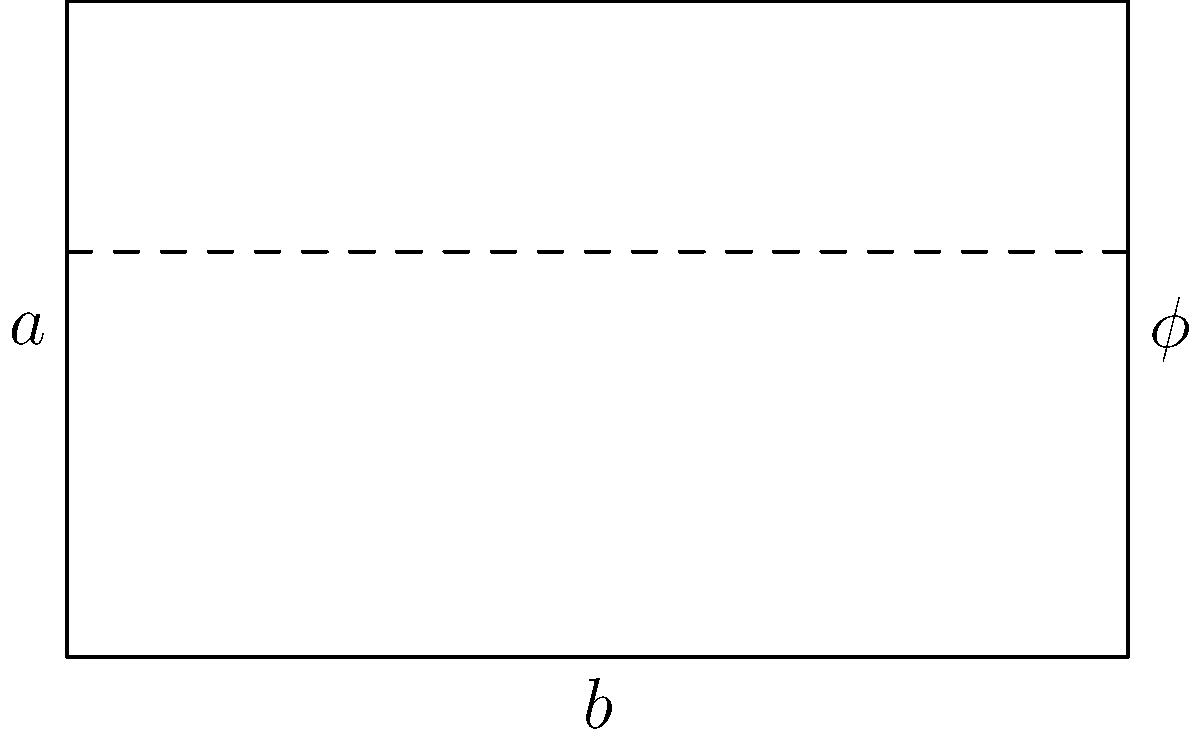In cinematography, the golden ratio ($\phi$) is often used to create visually pleasing compositions. Consider a rectangle with a width of 16 units and a height that follows the golden ratio. If we divide this rectangle into a square and a smaller rectangle, what would be the width of the smaller rectangle? Express your answer in terms of $\phi$. To solve this problem, let's follow these steps:

1) The golden ratio is defined as $\phi = \frac{a+b}{a} = \frac{a}{b}$, where $a$ is the longer side and $b$ is the shorter side.

2) We're given that the width of the rectangle is 16 units. Let's call the height $x$.

3) According to the golden ratio: $\frac{16}{x} = \phi$

4) This means: $x = \frac{16}{\phi}$

5) Now, if we divide this rectangle into a square and a smaller rectangle, the square will have sides of length $x$ (which is the height of the original rectangle).

6) The width of the smaller rectangle will be the difference between the total width and the width of the square:

   $16 - x = 16 - \frac{16}{\phi}$

7) We can factor out 16:

   $16(1 - \frac{1}{\phi})$

8) A property of the golden ratio is that $\frac{1}{\phi} = \phi - 1$

9) Substituting this in:

   $16(1 - (\phi - 1)) = 16(2 - \phi)$

Therefore, the width of the smaller rectangle is $16(2 - \phi)$ units.
Answer: $16(2 - \phi)$ 